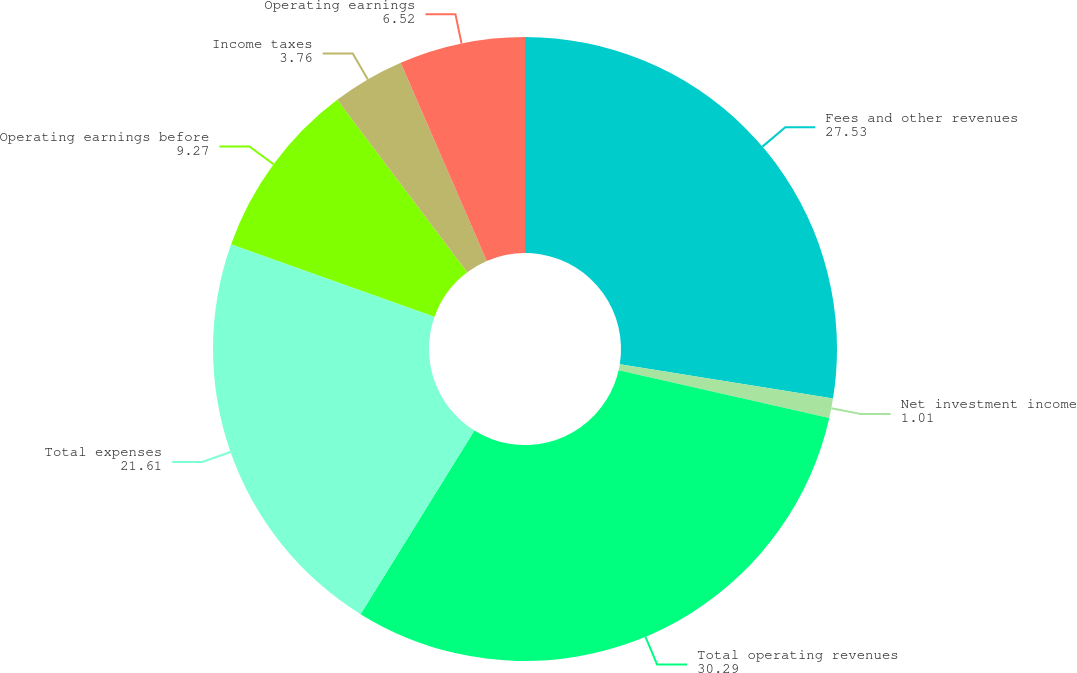Convert chart to OTSL. <chart><loc_0><loc_0><loc_500><loc_500><pie_chart><fcel>Fees and other revenues<fcel>Net investment income<fcel>Total operating revenues<fcel>Total expenses<fcel>Operating earnings before<fcel>Income taxes<fcel>Operating earnings<nl><fcel>27.53%<fcel>1.01%<fcel>30.29%<fcel>21.61%<fcel>9.27%<fcel>3.76%<fcel>6.52%<nl></chart> 